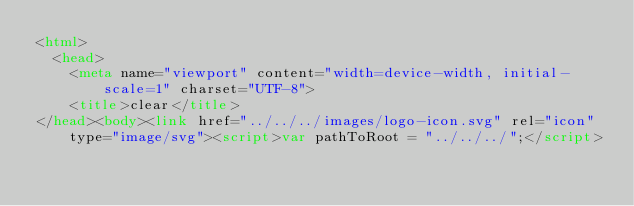Convert code to text. <code><loc_0><loc_0><loc_500><loc_500><_HTML_><html>
  <head>
    <meta name="viewport" content="width=device-width, initial-scale=1" charset="UTF-8">
    <title>clear</title>
</head><body><link href="../../../images/logo-icon.svg" rel="icon" type="image/svg"><script>var pathToRoot = "../../../";</script></code> 